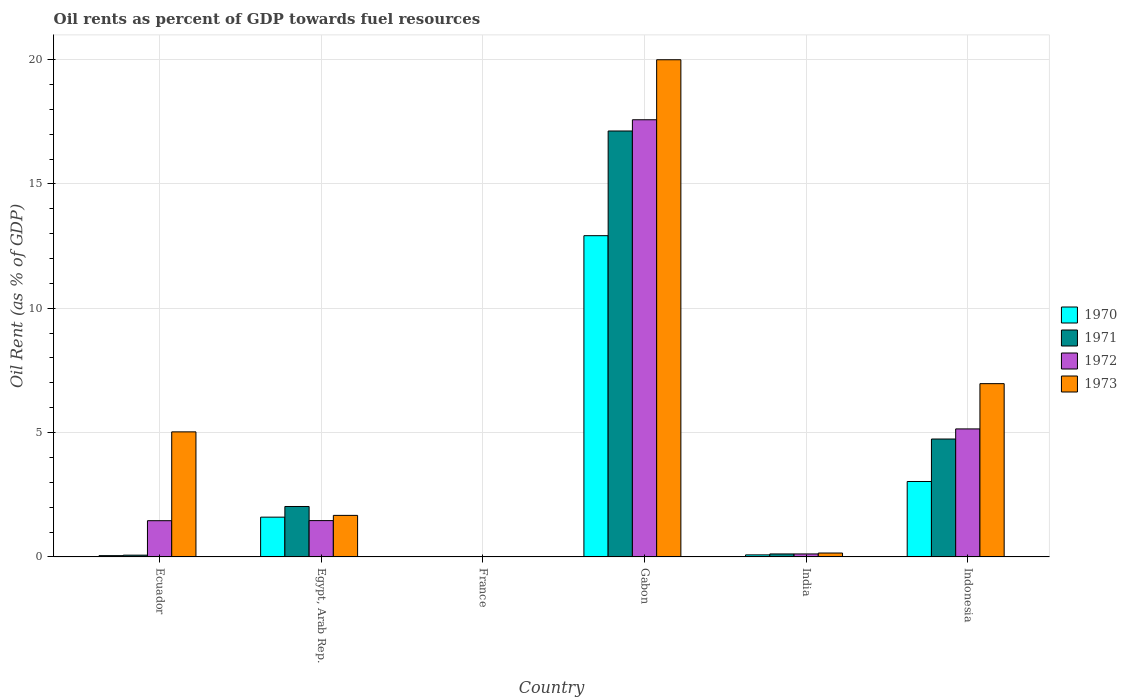How many different coloured bars are there?
Keep it short and to the point. 4. Are the number of bars per tick equal to the number of legend labels?
Ensure brevity in your answer.  Yes. How many bars are there on the 1st tick from the right?
Ensure brevity in your answer.  4. What is the label of the 4th group of bars from the left?
Provide a succinct answer. Gabon. What is the oil rent in 1973 in Gabon?
Ensure brevity in your answer.  19.99. Across all countries, what is the maximum oil rent in 1973?
Provide a succinct answer. 19.99. Across all countries, what is the minimum oil rent in 1973?
Offer a terse response. 0.01. In which country was the oil rent in 1971 maximum?
Your response must be concise. Gabon. In which country was the oil rent in 1972 minimum?
Provide a succinct answer. France. What is the total oil rent in 1970 in the graph?
Provide a succinct answer. 17.7. What is the difference between the oil rent in 1970 in France and that in India?
Give a very brief answer. -0.07. What is the difference between the oil rent in 1970 in France and the oil rent in 1973 in India?
Offer a very short reply. -0.15. What is the average oil rent in 1970 per country?
Provide a short and direct response. 2.95. What is the difference between the oil rent of/in 1973 and oil rent of/in 1971 in Gabon?
Ensure brevity in your answer.  2.87. What is the ratio of the oil rent in 1970 in Egypt, Arab Rep. to that in Indonesia?
Provide a succinct answer. 0.53. Is the oil rent in 1972 in Gabon less than that in India?
Offer a very short reply. No. What is the difference between the highest and the second highest oil rent in 1970?
Keep it short and to the point. -1.43. What is the difference between the highest and the lowest oil rent in 1971?
Give a very brief answer. 17.12. In how many countries, is the oil rent in 1972 greater than the average oil rent in 1972 taken over all countries?
Give a very brief answer. 2. What does the 4th bar from the left in Ecuador represents?
Provide a succinct answer. 1973. What does the 1st bar from the right in Egypt, Arab Rep. represents?
Provide a succinct answer. 1973. How many bars are there?
Your answer should be compact. 24. Are all the bars in the graph horizontal?
Your response must be concise. No. Does the graph contain any zero values?
Offer a terse response. No. Does the graph contain grids?
Give a very brief answer. Yes. How many legend labels are there?
Offer a terse response. 4. What is the title of the graph?
Make the answer very short. Oil rents as percent of GDP towards fuel resources. What is the label or title of the X-axis?
Ensure brevity in your answer.  Country. What is the label or title of the Y-axis?
Your answer should be compact. Oil Rent (as % of GDP). What is the Oil Rent (as % of GDP) in 1970 in Ecuador?
Your response must be concise. 0.05. What is the Oil Rent (as % of GDP) in 1971 in Ecuador?
Keep it short and to the point. 0.07. What is the Oil Rent (as % of GDP) in 1972 in Ecuador?
Your response must be concise. 1.46. What is the Oil Rent (as % of GDP) in 1973 in Ecuador?
Your answer should be very brief. 5.03. What is the Oil Rent (as % of GDP) in 1970 in Egypt, Arab Rep.?
Make the answer very short. 1.6. What is the Oil Rent (as % of GDP) of 1971 in Egypt, Arab Rep.?
Give a very brief answer. 2.03. What is the Oil Rent (as % of GDP) in 1972 in Egypt, Arab Rep.?
Your response must be concise. 1.46. What is the Oil Rent (as % of GDP) in 1973 in Egypt, Arab Rep.?
Offer a terse response. 1.67. What is the Oil Rent (as % of GDP) of 1970 in France?
Offer a terse response. 0.01. What is the Oil Rent (as % of GDP) in 1971 in France?
Your answer should be compact. 0.01. What is the Oil Rent (as % of GDP) in 1972 in France?
Provide a succinct answer. 0.01. What is the Oil Rent (as % of GDP) in 1973 in France?
Offer a very short reply. 0.01. What is the Oil Rent (as % of GDP) in 1970 in Gabon?
Your answer should be very brief. 12.92. What is the Oil Rent (as % of GDP) in 1971 in Gabon?
Ensure brevity in your answer.  17.13. What is the Oil Rent (as % of GDP) in 1972 in Gabon?
Offer a terse response. 17.58. What is the Oil Rent (as % of GDP) of 1973 in Gabon?
Your response must be concise. 19.99. What is the Oil Rent (as % of GDP) in 1970 in India?
Make the answer very short. 0.08. What is the Oil Rent (as % of GDP) in 1971 in India?
Your response must be concise. 0.12. What is the Oil Rent (as % of GDP) in 1972 in India?
Offer a very short reply. 0.12. What is the Oil Rent (as % of GDP) of 1973 in India?
Offer a terse response. 0.16. What is the Oil Rent (as % of GDP) of 1970 in Indonesia?
Give a very brief answer. 3.03. What is the Oil Rent (as % of GDP) of 1971 in Indonesia?
Provide a short and direct response. 4.74. What is the Oil Rent (as % of GDP) of 1972 in Indonesia?
Provide a short and direct response. 5.15. What is the Oil Rent (as % of GDP) in 1973 in Indonesia?
Offer a very short reply. 6.97. Across all countries, what is the maximum Oil Rent (as % of GDP) of 1970?
Provide a short and direct response. 12.92. Across all countries, what is the maximum Oil Rent (as % of GDP) of 1971?
Give a very brief answer. 17.13. Across all countries, what is the maximum Oil Rent (as % of GDP) of 1972?
Provide a succinct answer. 17.58. Across all countries, what is the maximum Oil Rent (as % of GDP) in 1973?
Your answer should be compact. 19.99. Across all countries, what is the minimum Oil Rent (as % of GDP) of 1970?
Provide a short and direct response. 0.01. Across all countries, what is the minimum Oil Rent (as % of GDP) in 1971?
Make the answer very short. 0.01. Across all countries, what is the minimum Oil Rent (as % of GDP) in 1972?
Provide a succinct answer. 0.01. Across all countries, what is the minimum Oil Rent (as % of GDP) in 1973?
Offer a very short reply. 0.01. What is the total Oil Rent (as % of GDP) in 1970 in the graph?
Provide a succinct answer. 17.7. What is the total Oil Rent (as % of GDP) in 1971 in the graph?
Give a very brief answer. 24.1. What is the total Oil Rent (as % of GDP) of 1972 in the graph?
Ensure brevity in your answer.  25.77. What is the total Oil Rent (as % of GDP) of 1973 in the graph?
Keep it short and to the point. 33.83. What is the difference between the Oil Rent (as % of GDP) in 1970 in Ecuador and that in Egypt, Arab Rep.?
Your response must be concise. -1.55. What is the difference between the Oil Rent (as % of GDP) in 1971 in Ecuador and that in Egypt, Arab Rep.?
Offer a terse response. -1.96. What is the difference between the Oil Rent (as % of GDP) of 1972 in Ecuador and that in Egypt, Arab Rep.?
Offer a terse response. -0. What is the difference between the Oil Rent (as % of GDP) in 1973 in Ecuador and that in Egypt, Arab Rep.?
Your response must be concise. 3.36. What is the difference between the Oil Rent (as % of GDP) of 1970 in Ecuador and that in France?
Offer a terse response. 0.04. What is the difference between the Oil Rent (as % of GDP) of 1971 in Ecuador and that in France?
Keep it short and to the point. 0.06. What is the difference between the Oil Rent (as % of GDP) in 1972 in Ecuador and that in France?
Your answer should be compact. 1.45. What is the difference between the Oil Rent (as % of GDP) in 1973 in Ecuador and that in France?
Provide a short and direct response. 5.02. What is the difference between the Oil Rent (as % of GDP) in 1970 in Ecuador and that in Gabon?
Provide a short and direct response. -12.87. What is the difference between the Oil Rent (as % of GDP) of 1971 in Ecuador and that in Gabon?
Your response must be concise. -17.06. What is the difference between the Oil Rent (as % of GDP) in 1972 in Ecuador and that in Gabon?
Keep it short and to the point. -16.12. What is the difference between the Oil Rent (as % of GDP) in 1973 in Ecuador and that in Gabon?
Ensure brevity in your answer.  -14.96. What is the difference between the Oil Rent (as % of GDP) in 1970 in Ecuador and that in India?
Keep it short and to the point. -0.03. What is the difference between the Oil Rent (as % of GDP) in 1971 in Ecuador and that in India?
Offer a terse response. -0.05. What is the difference between the Oil Rent (as % of GDP) in 1972 in Ecuador and that in India?
Give a very brief answer. 1.34. What is the difference between the Oil Rent (as % of GDP) of 1973 in Ecuador and that in India?
Your answer should be very brief. 4.87. What is the difference between the Oil Rent (as % of GDP) of 1970 in Ecuador and that in Indonesia?
Offer a terse response. -2.98. What is the difference between the Oil Rent (as % of GDP) of 1971 in Ecuador and that in Indonesia?
Keep it short and to the point. -4.67. What is the difference between the Oil Rent (as % of GDP) of 1972 in Ecuador and that in Indonesia?
Provide a short and direct response. -3.69. What is the difference between the Oil Rent (as % of GDP) of 1973 in Ecuador and that in Indonesia?
Give a very brief answer. -1.94. What is the difference between the Oil Rent (as % of GDP) of 1970 in Egypt, Arab Rep. and that in France?
Your response must be concise. 1.59. What is the difference between the Oil Rent (as % of GDP) in 1971 in Egypt, Arab Rep. and that in France?
Offer a terse response. 2.02. What is the difference between the Oil Rent (as % of GDP) in 1972 in Egypt, Arab Rep. and that in France?
Your response must be concise. 1.45. What is the difference between the Oil Rent (as % of GDP) of 1973 in Egypt, Arab Rep. and that in France?
Your answer should be very brief. 1.66. What is the difference between the Oil Rent (as % of GDP) in 1970 in Egypt, Arab Rep. and that in Gabon?
Make the answer very short. -11.32. What is the difference between the Oil Rent (as % of GDP) in 1971 in Egypt, Arab Rep. and that in Gabon?
Ensure brevity in your answer.  -15.1. What is the difference between the Oil Rent (as % of GDP) of 1972 in Egypt, Arab Rep. and that in Gabon?
Offer a very short reply. -16.12. What is the difference between the Oil Rent (as % of GDP) of 1973 in Egypt, Arab Rep. and that in Gabon?
Provide a short and direct response. -18.32. What is the difference between the Oil Rent (as % of GDP) of 1970 in Egypt, Arab Rep. and that in India?
Your answer should be compact. 1.52. What is the difference between the Oil Rent (as % of GDP) of 1971 in Egypt, Arab Rep. and that in India?
Your response must be concise. 1.91. What is the difference between the Oil Rent (as % of GDP) in 1972 in Egypt, Arab Rep. and that in India?
Your answer should be compact. 1.34. What is the difference between the Oil Rent (as % of GDP) of 1973 in Egypt, Arab Rep. and that in India?
Offer a very short reply. 1.51. What is the difference between the Oil Rent (as % of GDP) in 1970 in Egypt, Arab Rep. and that in Indonesia?
Your response must be concise. -1.43. What is the difference between the Oil Rent (as % of GDP) of 1971 in Egypt, Arab Rep. and that in Indonesia?
Make the answer very short. -2.71. What is the difference between the Oil Rent (as % of GDP) in 1972 in Egypt, Arab Rep. and that in Indonesia?
Keep it short and to the point. -3.69. What is the difference between the Oil Rent (as % of GDP) of 1973 in Egypt, Arab Rep. and that in Indonesia?
Keep it short and to the point. -5.3. What is the difference between the Oil Rent (as % of GDP) of 1970 in France and that in Gabon?
Offer a very short reply. -12.91. What is the difference between the Oil Rent (as % of GDP) of 1971 in France and that in Gabon?
Provide a succinct answer. -17.12. What is the difference between the Oil Rent (as % of GDP) in 1972 in France and that in Gabon?
Offer a terse response. -17.57. What is the difference between the Oil Rent (as % of GDP) of 1973 in France and that in Gabon?
Offer a very short reply. -19.98. What is the difference between the Oil Rent (as % of GDP) of 1970 in France and that in India?
Ensure brevity in your answer.  -0.07. What is the difference between the Oil Rent (as % of GDP) in 1971 in France and that in India?
Make the answer very short. -0.11. What is the difference between the Oil Rent (as % of GDP) in 1972 in France and that in India?
Make the answer very short. -0.11. What is the difference between the Oil Rent (as % of GDP) in 1973 in France and that in India?
Keep it short and to the point. -0.15. What is the difference between the Oil Rent (as % of GDP) in 1970 in France and that in Indonesia?
Keep it short and to the point. -3.02. What is the difference between the Oil Rent (as % of GDP) of 1971 in France and that in Indonesia?
Your response must be concise. -4.73. What is the difference between the Oil Rent (as % of GDP) of 1972 in France and that in Indonesia?
Your answer should be compact. -5.14. What is the difference between the Oil Rent (as % of GDP) in 1973 in France and that in Indonesia?
Offer a terse response. -6.96. What is the difference between the Oil Rent (as % of GDP) of 1970 in Gabon and that in India?
Make the answer very short. 12.84. What is the difference between the Oil Rent (as % of GDP) in 1971 in Gabon and that in India?
Your answer should be compact. 17.01. What is the difference between the Oil Rent (as % of GDP) of 1972 in Gabon and that in India?
Offer a terse response. 17.46. What is the difference between the Oil Rent (as % of GDP) of 1973 in Gabon and that in India?
Keep it short and to the point. 19.84. What is the difference between the Oil Rent (as % of GDP) in 1970 in Gabon and that in Indonesia?
Your response must be concise. 9.88. What is the difference between the Oil Rent (as % of GDP) of 1971 in Gabon and that in Indonesia?
Offer a terse response. 12.39. What is the difference between the Oil Rent (as % of GDP) of 1972 in Gabon and that in Indonesia?
Ensure brevity in your answer.  12.43. What is the difference between the Oil Rent (as % of GDP) of 1973 in Gabon and that in Indonesia?
Offer a very short reply. 13.03. What is the difference between the Oil Rent (as % of GDP) of 1970 in India and that in Indonesia?
Provide a short and direct response. -2.95. What is the difference between the Oil Rent (as % of GDP) of 1971 in India and that in Indonesia?
Give a very brief answer. -4.62. What is the difference between the Oil Rent (as % of GDP) in 1972 in India and that in Indonesia?
Offer a very short reply. -5.03. What is the difference between the Oil Rent (as % of GDP) of 1973 in India and that in Indonesia?
Offer a terse response. -6.81. What is the difference between the Oil Rent (as % of GDP) in 1970 in Ecuador and the Oil Rent (as % of GDP) in 1971 in Egypt, Arab Rep.?
Ensure brevity in your answer.  -1.98. What is the difference between the Oil Rent (as % of GDP) in 1970 in Ecuador and the Oil Rent (as % of GDP) in 1972 in Egypt, Arab Rep.?
Provide a short and direct response. -1.41. What is the difference between the Oil Rent (as % of GDP) of 1970 in Ecuador and the Oil Rent (as % of GDP) of 1973 in Egypt, Arab Rep.?
Your response must be concise. -1.62. What is the difference between the Oil Rent (as % of GDP) of 1971 in Ecuador and the Oil Rent (as % of GDP) of 1972 in Egypt, Arab Rep.?
Give a very brief answer. -1.39. What is the difference between the Oil Rent (as % of GDP) in 1971 in Ecuador and the Oil Rent (as % of GDP) in 1973 in Egypt, Arab Rep.?
Make the answer very short. -1.6. What is the difference between the Oil Rent (as % of GDP) in 1972 in Ecuador and the Oil Rent (as % of GDP) in 1973 in Egypt, Arab Rep.?
Make the answer very short. -0.21. What is the difference between the Oil Rent (as % of GDP) of 1970 in Ecuador and the Oil Rent (as % of GDP) of 1971 in France?
Provide a succinct answer. 0.04. What is the difference between the Oil Rent (as % of GDP) in 1970 in Ecuador and the Oil Rent (as % of GDP) in 1972 in France?
Give a very brief answer. 0.04. What is the difference between the Oil Rent (as % of GDP) in 1970 in Ecuador and the Oil Rent (as % of GDP) in 1973 in France?
Offer a very short reply. 0.04. What is the difference between the Oil Rent (as % of GDP) in 1971 in Ecuador and the Oil Rent (as % of GDP) in 1972 in France?
Your answer should be compact. 0.06. What is the difference between the Oil Rent (as % of GDP) in 1971 in Ecuador and the Oil Rent (as % of GDP) in 1973 in France?
Offer a terse response. 0.06. What is the difference between the Oil Rent (as % of GDP) in 1972 in Ecuador and the Oil Rent (as % of GDP) in 1973 in France?
Offer a terse response. 1.45. What is the difference between the Oil Rent (as % of GDP) of 1970 in Ecuador and the Oil Rent (as % of GDP) of 1971 in Gabon?
Offer a terse response. -17.08. What is the difference between the Oil Rent (as % of GDP) in 1970 in Ecuador and the Oil Rent (as % of GDP) in 1972 in Gabon?
Give a very brief answer. -17.53. What is the difference between the Oil Rent (as % of GDP) of 1970 in Ecuador and the Oil Rent (as % of GDP) of 1973 in Gabon?
Offer a terse response. -19.94. What is the difference between the Oil Rent (as % of GDP) of 1971 in Ecuador and the Oil Rent (as % of GDP) of 1972 in Gabon?
Provide a succinct answer. -17.51. What is the difference between the Oil Rent (as % of GDP) of 1971 in Ecuador and the Oil Rent (as % of GDP) of 1973 in Gabon?
Keep it short and to the point. -19.92. What is the difference between the Oil Rent (as % of GDP) in 1972 in Ecuador and the Oil Rent (as % of GDP) in 1973 in Gabon?
Make the answer very short. -18.54. What is the difference between the Oil Rent (as % of GDP) of 1970 in Ecuador and the Oil Rent (as % of GDP) of 1971 in India?
Your answer should be compact. -0.07. What is the difference between the Oil Rent (as % of GDP) of 1970 in Ecuador and the Oil Rent (as % of GDP) of 1972 in India?
Make the answer very short. -0.07. What is the difference between the Oil Rent (as % of GDP) in 1970 in Ecuador and the Oil Rent (as % of GDP) in 1973 in India?
Your answer should be compact. -0.11. What is the difference between the Oil Rent (as % of GDP) of 1971 in Ecuador and the Oil Rent (as % of GDP) of 1972 in India?
Make the answer very short. -0.05. What is the difference between the Oil Rent (as % of GDP) of 1971 in Ecuador and the Oil Rent (as % of GDP) of 1973 in India?
Give a very brief answer. -0.09. What is the difference between the Oil Rent (as % of GDP) of 1972 in Ecuador and the Oil Rent (as % of GDP) of 1973 in India?
Ensure brevity in your answer.  1.3. What is the difference between the Oil Rent (as % of GDP) of 1970 in Ecuador and the Oil Rent (as % of GDP) of 1971 in Indonesia?
Your answer should be very brief. -4.69. What is the difference between the Oil Rent (as % of GDP) of 1970 in Ecuador and the Oil Rent (as % of GDP) of 1972 in Indonesia?
Offer a terse response. -5.1. What is the difference between the Oil Rent (as % of GDP) of 1970 in Ecuador and the Oil Rent (as % of GDP) of 1973 in Indonesia?
Your answer should be very brief. -6.92. What is the difference between the Oil Rent (as % of GDP) of 1971 in Ecuador and the Oil Rent (as % of GDP) of 1972 in Indonesia?
Your answer should be very brief. -5.08. What is the difference between the Oil Rent (as % of GDP) in 1971 in Ecuador and the Oil Rent (as % of GDP) in 1973 in Indonesia?
Provide a succinct answer. -6.9. What is the difference between the Oil Rent (as % of GDP) of 1972 in Ecuador and the Oil Rent (as % of GDP) of 1973 in Indonesia?
Your response must be concise. -5.51. What is the difference between the Oil Rent (as % of GDP) of 1970 in Egypt, Arab Rep. and the Oil Rent (as % of GDP) of 1971 in France?
Keep it short and to the point. 1.59. What is the difference between the Oil Rent (as % of GDP) in 1970 in Egypt, Arab Rep. and the Oil Rent (as % of GDP) in 1972 in France?
Provide a short and direct response. 1.59. What is the difference between the Oil Rent (as % of GDP) in 1970 in Egypt, Arab Rep. and the Oil Rent (as % of GDP) in 1973 in France?
Provide a short and direct response. 1.59. What is the difference between the Oil Rent (as % of GDP) of 1971 in Egypt, Arab Rep. and the Oil Rent (as % of GDP) of 1972 in France?
Ensure brevity in your answer.  2.02. What is the difference between the Oil Rent (as % of GDP) in 1971 in Egypt, Arab Rep. and the Oil Rent (as % of GDP) in 1973 in France?
Keep it short and to the point. 2.02. What is the difference between the Oil Rent (as % of GDP) in 1972 in Egypt, Arab Rep. and the Oil Rent (as % of GDP) in 1973 in France?
Keep it short and to the point. 1.45. What is the difference between the Oil Rent (as % of GDP) in 1970 in Egypt, Arab Rep. and the Oil Rent (as % of GDP) in 1971 in Gabon?
Offer a terse response. -15.53. What is the difference between the Oil Rent (as % of GDP) in 1970 in Egypt, Arab Rep. and the Oil Rent (as % of GDP) in 1972 in Gabon?
Your answer should be very brief. -15.98. What is the difference between the Oil Rent (as % of GDP) of 1970 in Egypt, Arab Rep. and the Oil Rent (as % of GDP) of 1973 in Gabon?
Your answer should be very brief. -18.39. What is the difference between the Oil Rent (as % of GDP) of 1971 in Egypt, Arab Rep. and the Oil Rent (as % of GDP) of 1972 in Gabon?
Provide a short and direct response. -15.55. What is the difference between the Oil Rent (as % of GDP) of 1971 in Egypt, Arab Rep. and the Oil Rent (as % of GDP) of 1973 in Gabon?
Offer a very short reply. -17.97. What is the difference between the Oil Rent (as % of GDP) in 1972 in Egypt, Arab Rep. and the Oil Rent (as % of GDP) in 1973 in Gabon?
Your answer should be very brief. -18.53. What is the difference between the Oil Rent (as % of GDP) of 1970 in Egypt, Arab Rep. and the Oil Rent (as % of GDP) of 1971 in India?
Ensure brevity in your answer.  1.48. What is the difference between the Oil Rent (as % of GDP) of 1970 in Egypt, Arab Rep. and the Oil Rent (as % of GDP) of 1972 in India?
Offer a terse response. 1.48. What is the difference between the Oil Rent (as % of GDP) of 1970 in Egypt, Arab Rep. and the Oil Rent (as % of GDP) of 1973 in India?
Make the answer very short. 1.44. What is the difference between the Oil Rent (as % of GDP) in 1971 in Egypt, Arab Rep. and the Oil Rent (as % of GDP) in 1972 in India?
Provide a short and direct response. 1.91. What is the difference between the Oil Rent (as % of GDP) in 1971 in Egypt, Arab Rep. and the Oil Rent (as % of GDP) in 1973 in India?
Make the answer very short. 1.87. What is the difference between the Oil Rent (as % of GDP) of 1972 in Egypt, Arab Rep. and the Oil Rent (as % of GDP) of 1973 in India?
Offer a very short reply. 1.3. What is the difference between the Oil Rent (as % of GDP) of 1970 in Egypt, Arab Rep. and the Oil Rent (as % of GDP) of 1971 in Indonesia?
Your answer should be compact. -3.14. What is the difference between the Oil Rent (as % of GDP) of 1970 in Egypt, Arab Rep. and the Oil Rent (as % of GDP) of 1972 in Indonesia?
Provide a succinct answer. -3.55. What is the difference between the Oil Rent (as % of GDP) of 1970 in Egypt, Arab Rep. and the Oil Rent (as % of GDP) of 1973 in Indonesia?
Ensure brevity in your answer.  -5.37. What is the difference between the Oil Rent (as % of GDP) of 1971 in Egypt, Arab Rep. and the Oil Rent (as % of GDP) of 1972 in Indonesia?
Your answer should be compact. -3.12. What is the difference between the Oil Rent (as % of GDP) in 1971 in Egypt, Arab Rep. and the Oil Rent (as % of GDP) in 1973 in Indonesia?
Give a very brief answer. -4.94. What is the difference between the Oil Rent (as % of GDP) in 1972 in Egypt, Arab Rep. and the Oil Rent (as % of GDP) in 1973 in Indonesia?
Your answer should be compact. -5.51. What is the difference between the Oil Rent (as % of GDP) of 1970 in France and the Oil Rent (as % of GDP) of 1971 in Gabon?
Provide a succinct answer. -17.12. What is the difference between the Oil Rent (as % of GDP) of 1970 in France and the Oil Rent (as % of GDP) of 1972 in Gabon?
Your response must be concise. -17.57. What is the difference between the Oil Rent (as % of GDP) in 1970 in France and the Oil Rent (as % of GDP) in 1973 in Gabon?
Offer a very short reply. -19.98. What is the difference between the Oil Rent (as % of GDP) in 1971 in France and the Oil Rent (as % of GDP) in 1972 in Gabon?
Keep it short and to the point. -17.57. What is the difference between the Oil Rent (as % of GDP) of 1971 in France and the Oil Rent (as % of GDP) of 1973 in Gabon?
Keep it short and to the point. -19.98. What is the difference between the Oil Rent (as % of GDP) of 1972 in France and the Oil Rent (as % of GDP) of 1973 in Gabon?
Your answer should be compact. -19.99. What is the difference between the Oil Rent (as % of GDP) of 1970 in France and the Oil Rent (as % of GDP) of 1971 in India?
Provide a succinct answer. -0.11. What is the difference between the Oil Rent (as % of GDP) in 1970 in France and the Oil Rent (as % of GDP) in 1972 in India?
Give a very brief answer. -0.11. What is the difference between the Oil Rent (as % of GDP) in 1970 in France and the Oil Rent (as % of GDP) in 1973 in India?
Provide a succinct answer. -0.15. What is the difference between the Oil Rent (as % of GDP) in 1971 in France and the Oil Rent (as % of GDP) in 1972 in India?
Offer a terse response. -0.11. What is the difference between the Oil Rent (as % of GDP) in 1971 in France and the Oil Rent (as % of GDP) in 1973 in India?
Offer a terse response. -0.14. What is the difference between the Oil Rent (as % of GDP) of 1972 in France and the Oil Rent (as % of GDP) of 1973 in India?
Keep it short and to the point. -0.15. What is the difference between the Oil Rent (as % of GDP) of 1970 in France and the Oil Rent (as % of GDP) of 1971 in Indonesia?
Provide a short and direct response. -4.73. What is the difference between the Oil Rent (as % of GDP) of 1970 in France and the Oil Rent (as % of GDP) of 1972 in Indonesia?
Keep it short and to the point. -5.14. What is the difference between the Oil Rent (as % of GDP) of 1970 in France and the Oil Rent (as % of GDP) of 1973 in Indonesia?
Your response must be concise. -6.96. What is the difference between the Oil Rent (as % of GDP) of 1971 in France and the Oil Rent (as % of GDP) of 1972 in Indonesia?
Make the answer very short. -5.14. What is the difference between the Oil Rent (as % of GDP) in 1971 in France and the Oil Rent (as % of GDP) in 1973 in Indonesia?
Your response must be concise. -6.96. What is the difference between the Oil Rent (as % of GDP) in 1972 in France and the Oil Rent (as % of GDP) in 1973 in Indonesia?
Your answer should be compact. -6.96. What is the difference between the Oil Rent (as % of GDP) in 1970 in Gabon and the Oil Rent (as % of GDP) in 1971 in India?
Your answer should be compact. 12.8. What is the difference between the Oil Rent (as % of GDP) of 1970 in Gabon and the Oil Rent (as % of GDP) of 1972 in India?
Your response must be concise. 12.8. What is the difference between the Oil Rent (as % of GDP) in 1970 in Gabon and the Oil Rent (as % of GDP) in 1973 in India?
Give a very brief answer. 12.76. What is the difference between the Oil Rent (as % of GDP) of 1971 in Gabon and the Oil Rent (as % of GDP) of 1972 in India?
Keep it short and to the point. 17.01. What is the difference between the Oil Rent (as % of GDP) in 1971 in Gabon and the Oil Rent (as % of GDP) in 1973 in India?
Give a very brief answer. 16.97. What is the difference between the Oil Rent (as % of GDP) of 1972 in Gabon and the Oil Rent (as % of GDP) of 1973 in India?
Give a very brief answer. 17.42. What is the difference between the Oil Rent (as % of GDP) of 1970 in Gabon and the Oil Rent (as % of GDP) of 1971 in Indonesia?
Offer a terse response. 8.18. What is the difference between the Oil Rent (as % of GDP) in 1970 in Gabon and the Oil Rent (as % of GDP) in 1972 in Indonesia?
Your answer should be compact. 7.77. What is the difference between the Oil Rent (as % of GDP) in 1970 in Gabon and the Oil Rent (as % of GDP) in 1973 in Indonesia?
Provide a short and direct response. 5.95. What is the difference between the Oil Rent (as % of GDP) in 1971 in Gabon and the Oil Rent (as % of GDP) in 1972 in Indonesia?
Give a very brief answer. 11.98. What is the difference between the Oil Rent (as % of GDP) in 1971 in Gabon and the Oil Rent (as % of GDP) in 1973 in Indonesia?
Your answer should be compact. 10.16. What is the difference between the Oil Rent (as % of GDP) of 1972 in Gabon and the Oil Rent (as % of GDP) of 1973 in Indonesia?
Give a very brief answer. 10.61. What is the difference between the Oil Rent (as % of GDP) in 1970 in India and the Oil Rent (as % of GDP) in 1971 in Indonesia?
Offer a very short reply. -4.66. What is the difference between the Oil Rent (as % of GDP) of 1970 in India and the Oil Rent (as % of GDP) of 1972 in Indonesia?
Your answer should be very brief. -5.07. What is the difference between the Oil Rent (as % of GDP) of 1970 in India and the Oil Rent (as % of GDP) of 1973 in Indonesia?
Make the answer very short. -6.89. What is the difference between the Oil Rent (as % of GDP) in 1971 in India and the Oil Rent (as % of GDP) in 1972 in Indonesia?
Provide a succinct answer. -5.03. What is the difference between the Oil Rent (as % of GDP) of 1971 in India and the Oil Rent (as % of GDP) of 1973 in Indonesia?
Your answer should be compact. -6.85. What is the difference between the Oil Rent (as % of GDP) in 1972 in India and the Oil Rent (as % of GDP) in 1973 in Indonesia?
Your answer should be compact. -6.85. What is the average Oil Rent (as % of GDP) of 1970 per country?
Your answer should be compact. 2.95. What is the average Oil Rent (as % of GDP) of 1971 per country?
Make the answer very short. 4.02. What is the average Oil Rent (as % of GDP) in 1972 per country?
Keep it short and to the point. 4.3. What is the average Oil Rent (as % of GDP) of 1973 per country?
Offer a very short reply. 5.64. What is the difference between the Oil Rent (as % of GDP) in 1970 and Oil Rent (as % of GDP) in 1971 in Ecuador?
Keep it short and to the point. -0.02. What is the difference between the Oil Rent (as % of GDP) of 1970 and Oil Rent (as % of GDP) of 1972 in Ecuador?
Provide a succinct answer. -1.41. What is the difference between the Oil Rent (as % of GDP) in 1970 and Oil Rent (as % of GDP) in 1973 in Ecuador?
Provide a succinct answer. -4.98. What is the difference between the Oil Rent (as % of GDP) in 1971 and Oil Rent (as % of GDP) in 1972 in Ecuador?
Provide a succinct answer. -1.39. What is the difference between the Oil Rent (as % of GDP) of 1971 and Oil Rent (as % of GDP) of 1973 in Ecuador?
Provide a short and direct response. -4.96. What is the difference between the Oil Rent (as % of GDP) of 1972 and Oil Rent (as % of GDP) of 1973 in Ecuador?
Your answer should be compact. -3.57. What is the difference between the Oil Rent (as % of GDP) in 1970 and Oil Rent (as % of GDP) in 1971 in Egypt, Arab Rep.?
Make the answer very short. -0.43. What is the difference between the Oil Rent (as % of GDP) in 1970 and Oil Rent (as % of GDP) in 1972 in Egypt, Arab Rep.?
Make the answer very short. 0.14. What is the difference between the Oil Rent (as % of GDP) of 1970 and Oil Rent (as % of GDP) of 1973 in Egypt, Arab Rep.?
Your response must be concise. -0.07. What is the difference between the Oil Rent (as % of GDP) in 1971 and Oil Rent (as % of GDP) in 1972 in Egypt, Arab Rep.?
Keep it short and to the point. 0.57. What is the difference between the Oil Rent (as % of GDP) of 1971 and Oil Rent (as % of GDP) of 1973 in Egypt, Arab Rep.?
Make the answer very short. 0.36. What is the difference between the Oil Rent (as % of GDP) in 1972 and Oil Rent (as % of GDP) in 1973 in Egypt, Arab Rep.?
Provide a succinct answer. -0.21. What is the difference between the Oil Rent (as % of GDP) of 1970 and Oil Rent (as % of GDP) of 1971 in France?
Give a very brief answer. -0. What is the difference between the Oil Rent (as % of GDP) of 1970 and Oil Rent (as % of GDP) of 1972 in France?
Ensure brevity in your answer.  0. What is the difference between the Oil Rent (as % of GDP) of 1970 and Oil Rent (as % of GDP) of 1973 in France?
Provide a short and direct response. 0. What is the difference between the Oil Rent (as % of GDP) of 1971 and Oil Rent (as % of GDP) of 1972 in France?
Your response must be concise. 0. What is the difference between the Oil Rent (as % of GDP) of 1971 and Oil Rent (as % of GDP) of 1973 in France?
Make the answer very short. 0. What is the difference between the Oil Rent (as % of GDP) in 1972 and Oil Rent (as % of GDP) in 1973 in France?
Provide a succinct answer. -0. What is the difference between the Oil Rent (as % of GDP) in 1970 and Oil Rent (as % of GDP) in 1971 in Gabon?
Offer a very short reply. -4.21. What is the difference between the Oil Rent (as % of GDP) in 1970 and Oil Rent (as % of GDP) in 1972 in Gabon?
Offer a very short reply. -4.66. What is the difference between the Oil Rent (as % of GDP) in 1970 and Oil Rent (as % of GDP) in 1973 in Gabon?
Provide a short and direct response. -7.08. What is the difference between the Oil Rent (as % of GDP) in 1971 and Oil Rent (as % of GDP) in 1972 in Gabon?
Your answer should be very brief. -0.45. What is the difference between the Oil Rent (as % of GDP) in 1971 and Oil Rent (as % of GDP) in 1973 in Gabon?
Your response must be concise. -2.87. What is the difference between the Oil Rent (as % of GDP) of 1972 and Oil Rent (as % of GDP) of 1973 in Gabon?
Make the answer very short. -2.41. What is the difference between the Oil Rent (as % of GDP) of 1970 and Oil Rent (as % of GDP) of 1971 in India?
Your answer should be very brief. -0.04. What is the difference between the Oil Rent (as % of GDP) in 1970 and Oil Rent (as % of GDP) in 1972 in India?
Keep it short and to the point. -0.04. What is the difference between the Oil Rent (as % of GDP) in 1970 and Oil Rent (as % of GDP) in 1973 in India?
Your answer should be very brief. -0.07. What is the difference between the Oil Rent (as % of GDP) of 1971 and Oil Rent (as % of GDP) of 1972 in India?
Your answer should be very brief. -0. What is the difference between the Oil Rent (as % of GDP) of 1971 and Oil Rent (as % of GDP) of 1973 in India?
Keep it short and to the point. -0.04. What is the difference between the Oil Rent (as % of GDP) in 1972 and Oil Rent (as % of GDP) in 1973 in India?
Make the answer very short. -0.04. What is the difference between the Oil Rent (as % of GDP) in 1970 and Oil Rent (as % of GDP) in 1971 in Indonesia?
Offer a terse response. -1.71. What is the difference between the Oil Rent (as % of GDP) in 1970 and Oil Rent (as % of GDP) in 1972 in Indonesia?
Your answer should be very brief. -2.11. What is the difference between the Oil Rent (as % of GDP) in 1970 and Oil Rent (as % of GDP) in 1973 in Indonesia?
Keep it short and to the point. -3.93. What is the difference between the Oil Rent (as % of GDP) of 1971 and Oil Rent (as % of GDP) of 1972 in Indonesia?
Your answer should be very brief. -0.41. What is the difference between the Oil Rent (as % of GDP) of 1971 and Oil Rent (as % of GDP) of 1973 in Indonesia?
Your answer should be very brief. -2.23. What is the difference between the Oil Rent (as % of GDP) of 1972 and Oil Rent (as % of GDP) of 1973 in Indonesia?
Give a very brief answer. -1.82. What is the ratio of the Oil Rent (as % of GDP) in 1970 in Ecuador to that in Egypt, Arab Rep.?
Your response must be concise. 0.03. What is the ratio of the Oil Rent (as % of GDP) in 1971 in Ecuador to that in Egypt, Arab Rep.?
Provide a short and direct response. 0.03. What is the ratio of the Oil Rent (as % of GDP) of 1972 in Ecuador to that in Egypt, Arab Rep.?
Give a very brief answer. 1. What is the ratio of the Oil Rent (as % of GDP) of 1973 in Ecuador to that in Egypt, Arab Rep.?
Offer a terse response. 3.01. What is the ratio of the Oil Rent (as % of GDP) in 1970 in Ecuador to that in France?
Offer a terse response. 4.52. What is the ratio of the Oil Rent (as % of GDP) of 1971 in Ecuador to that in France?
Ensure brevity in your answer.  5.74. What is the ratio of the Oil Rent (as % of GDP) of 1972 in Ecuador to that in France?
Your answer should be compact. 171.48. What is the ratio of the Oil Rent (as % of GDP) of 1973 in Ecuador to that in France?
Your answer should be compact. 569.07. What is the ratio of the Oil Rent (as % of GDP) in 1970 in Ecuador to that in Gabon?
Your response must be concise. 0. What is the ratio of the Oil Rent (as % of GDP) of 1971 in Ecuador to that in Gabon?
Your answer should be very brief. 0. What is the ratio of the Oil Rent (as % of GDP) of 1972 in Ecuador to that in Gabon?
Your answer should be compact. 0.08. What is the ratio of the Oil Rent (as % of GDP) of 1973 in Ecuador to that in Gabon?
Make the answer very short. 0.25. What is the ratio of the Oil Rent (as % of GDP) of 1970 in Ecuador to that in India?
Provide a succinct answer. 0.63. What is the ratio of the Oil Rent (as % of GDP) in 1971 in Ecuador to that in India?
Make the answer very short. 0.59. What is the ratio of the Oil Rent (as % of GDP) in 1972 in Ecuador to that in India?
Give a very brief answer. 12.12. What is the ratio of the Oil Rent (as % of GDP) of 1973 in Ecuador to that in India?
Provide a short and direct response. 31.99. What is the ratio of the Oil Rent (as % of GDP) of 1970 in Ecuador to that in Indonesia?
Give a very brief answer. 0.02. What is the ratio of the Oil Rent (as % of GDP) in 1971 in Ecuador to that in Indonesia?
Make the answer very short. 0.01. What is the ratio of the Oil Rent (as % of GDP) of 1972 in Ecuador to that in Indonesia?
Provide a short and direct response. 0.28. What is the ratio of the Oil Rent (as % of GDP) of 1973 in Ecuador to that in Indonesia?
Your response must be concise. 0.72. What is the ratio of the Oil Rent (as % of GDP) in 1970 in Egypt, Arab Rep. to that in France?
Provide a succinct answer. 139.1. What is the ratio of the Oil Rent (as % of GDP) of 1971 in Egypt, Arab Rep. to that in France?
Provide a succinct answer. 164.4. What is the ratio of the Oil Rent (as % of GDP) in 1972 in Egypt, Arab Rep. to that in France?
Give a very brief answer. 171.93. What is the ratio of the Oil Rent (as % of GDP) in 1973 in Egypt, Arab Rep. to that in France?
Provide a succinct answer. 189.03. What is the ratio of the Oil Rent (as % of GDP) of 1970 in Egypt, Arab Rep. to that in Gabon?
Your answer should be compact. 0.12. What is the ratio of the Oil Rent (as % of GDP) of 1971 in Egypt, Arab Rep. to that in Gabon?
Ensure brevity in your answer.  0.12. What is the ratio of the Oil Rent (as % of GDP) in 1972 in Egypt, Arab Rep. to that in Gabon?
Your answer should be compact. 0.08. What is the ratio of the Oil Rent (as % of GDP) in 1973 in Egypt, Arab Rep. to that in Gabon?
Make the answer very short. 0.08. What is the ratio of the Oil Rent (as % of GDP) in 1970 in Egypt, Arab Rep. to that in India?
Offer a very short reply. 19.39. What is the ratio of the Oil Rent (as % of GDP) in 1971 in Egypt, Arab Rep. to that in India?
Give a very brief answer. 16.93. What is the ratio of the Oil Rent (as % of GDP) of 1972 in Egypt, Arab Rep. to that in India?
Make the answer very short. 12.16. What is the ratio of the Oil Rent (as % of GDP) of 1973 in Egypt, Arab Rep. to that in India?
Offer a terse response. 10.63. What is the ratio of the Oil Rent (as % of GDP) of 1970 in Egypt, Arab Rep. to that in Indonesia?
Give a very brief answer. 0.53. What is the ratio of the Oil Rent (as % of GDP) of 1971 in Egypt, Arab Rep. to that in Indonesia?
Give a very brief answer. 0.43. What is the ratio of the Oil Rent (as % of GDP) in 1972 in Egypt, Arab Rep. to that in Indonesia?
Your response must be concise. 0.28. What is the ratio of the Oil Rent (as % of GDP) of 1973 in Egypt, Arab Rep. to that in Indonesia?
Offer a very short reply. 0.24. What is the ratio of the Oil Rent (as % of GDP) of 1970 in France to that in Gabon?
Provide a succinct answer. 0. What is the ratio of the Oil Rent (as % of GDP) in 1971 in France to that in Gabon?
Your answer should be very brief. 0. What is the ratio of the Oil Rent (as % of GDP) of 1972 in France to that in Gabon?
Offer a very short reply. 0. What is the ratio of the Oil Rent (as % of GDP) of 1970 in France to that in India?
Your response must be concise. 0.14. What is the ratio of the Oil Rent (as % of GDP) of 1971 in France to that in India?
Offer a very short reply. 0.1. What is the ratio of the Oil Rent (as % of GDP) in 1972 in France to that in India?
Keep it short and to the point. 0.07. What is the ratio of the Oil Rent (as % of GDP) of 1973 in France to that in India?
Provide a succinct answer. 0.06. What is the ratio of the Oil Rent (as % of GDP) in 1970 in France to that in Indonesia?
Offer a terse response. 0. What is the ratio of the Oil Rent (as % of GDP) of 1971 in France to that in Indonesia?
Your answer should be very brief. 0. What is the ratio of the Oil Rent (as % of GDP) of 1972 in France to that in Indonesia?
Provide a succinct answer. 0. What is the ratio of the Oil Rent (as % of GDP) in 1973 in France to that in Indonesia?
Offer a very short reply. 0. What is the ratio of the Oil Rent (as % of GDP) in 1970 in Gabon to that in India?
Provide a succinct answer. 156.62. What is the ratio of the Oil Rent (as % of GDP) of 1971 in Gabon to that in India?
Keep it short and to the point. 142.99. What is the ratio of the Oil Rent (as % of GDP) in 1972 in Gabon to that in India?
Provide a succinct answer. 146.29. What is the ratio of the Oil Rent (as % of GDP) in 1973 in Gabon to that in India?
Your answer should be very brief. 127.16. What is the ratio of the Oil Rent (as % of GDP) of 1970 in Gabon to that in Indonesia?
Ensure brevity in your answer.  4.26. What is the ratio of the Oil Rent (as % of GDP) in 1971 in Gabon to that in Indonesia?
Offer a very short reply. 3.61. What is the ratio of the Oil Rent (as % of GDP) of 1972 in Gabon to that in Indonesia?
Ensure brevity in your answer.  3.41. What is the ratio of the Oil Rent (as % of GDP) of 1973 in Gabon to that in Indonesia?
Your answer should be very brief. 2.87. What is the ratio of the Oil Rent (as % of GDP) in 1970 in India to that in Indonesia?
Keep it short and to the point. 0.03. What is the ratio of the Oil Rent (as % of GDP) of 1971 in India to that in Indonesia?
Make the answer very short. 0.03. What is the ratio of the Oil Rent (as % of GDP) of 1972 in India to that in Indonesia?
Your answer should be compact. 0.02. What is the ratio of the Oil Rent (as % of GDP) in 1973 in India to that in Indonesia?
Ensure brevity in your answer.  0.02. What is the difference between the highest and the second highest Oil Rent (as % of GDP) in 1970?
Your response must be concise. 9.88. What is the difference between the highest and the second highest Oil Rent (as % of GDP) of 1971?
Make the answer very short. 12.39. What is the difference between the highest and the second highest Oil Rent (as % of GDP) in 1972?
Provide a short and direct response. 12.43. What is the difference between the highest and the second highest Oil Rent (as % of GDP) in 1973?
Ensure brevity in your answer.  13.03. What is the difference between the highest and the lowest Oil Rent (as % of GDP) of 1970?
Offer a very short reply. 12.91. What is the difference between the highest and the lowest Oil Rent (as % of GDP) of 1971?
Provide a short and direct response. 17.12. What is the difference between the highest and the lowest Oil Rent (as % of GDP) in 1972?
Keep it short and to the point. 17.57. What is the difference between the highest and the lowest Oil Rent (as % of GDP) in 1973?
Provide a short and direct response. 19.98. 